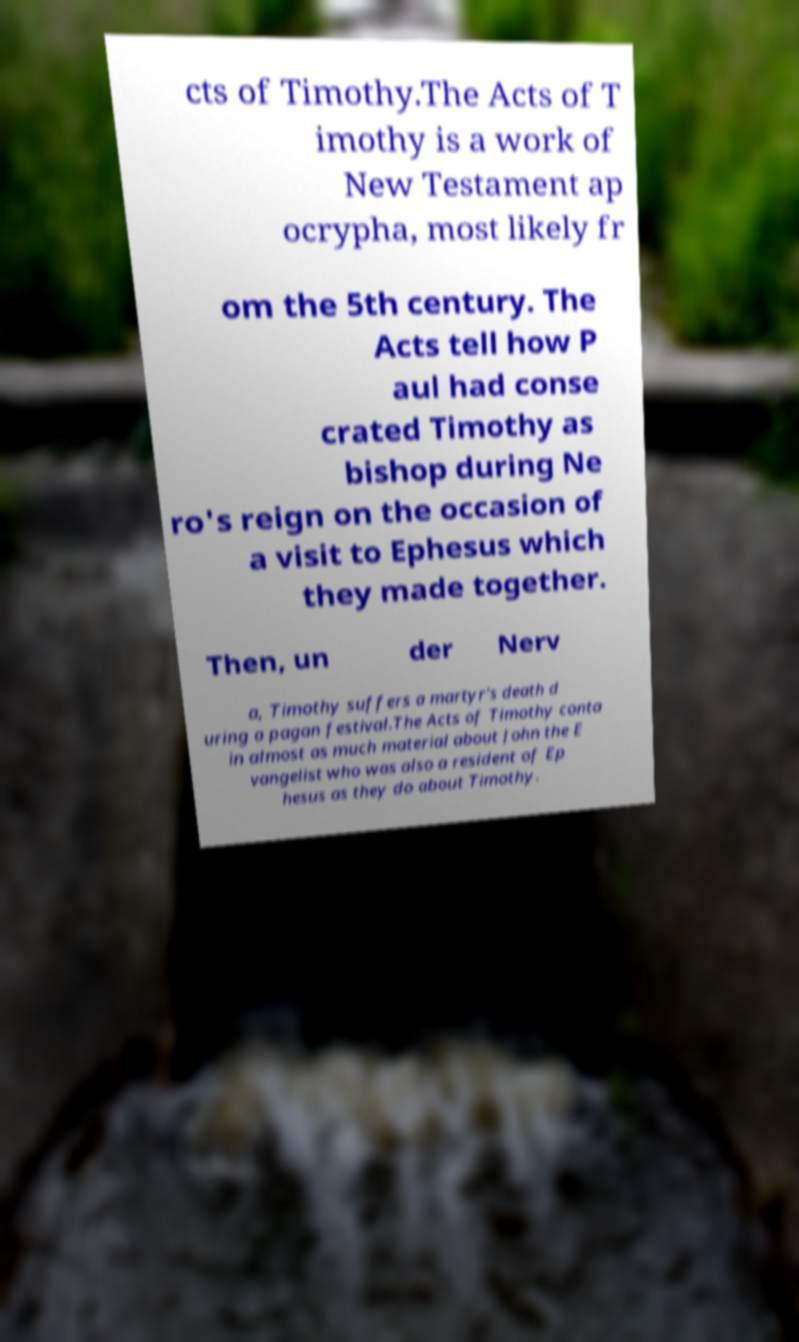There's text embedded in this image that I need extracted. Can you transcribe it verbatim? cts of Timothy.The Acts of T imothy is a work of New Testament ap ocrypha, most likely fr om the 5th century. The Acts tell how P aul had conse crated Timothy as bishop during Ne ro's reign on the occasion of a visit to Ephesus which they made together. Then, un der Nerv a, Timothy suffers a martyr's death d uring a pagan festival.The Acts of Timothy conta in almost as much material about John the E vangelist who was also a resident of Ep hesus as they do about Timothy. 